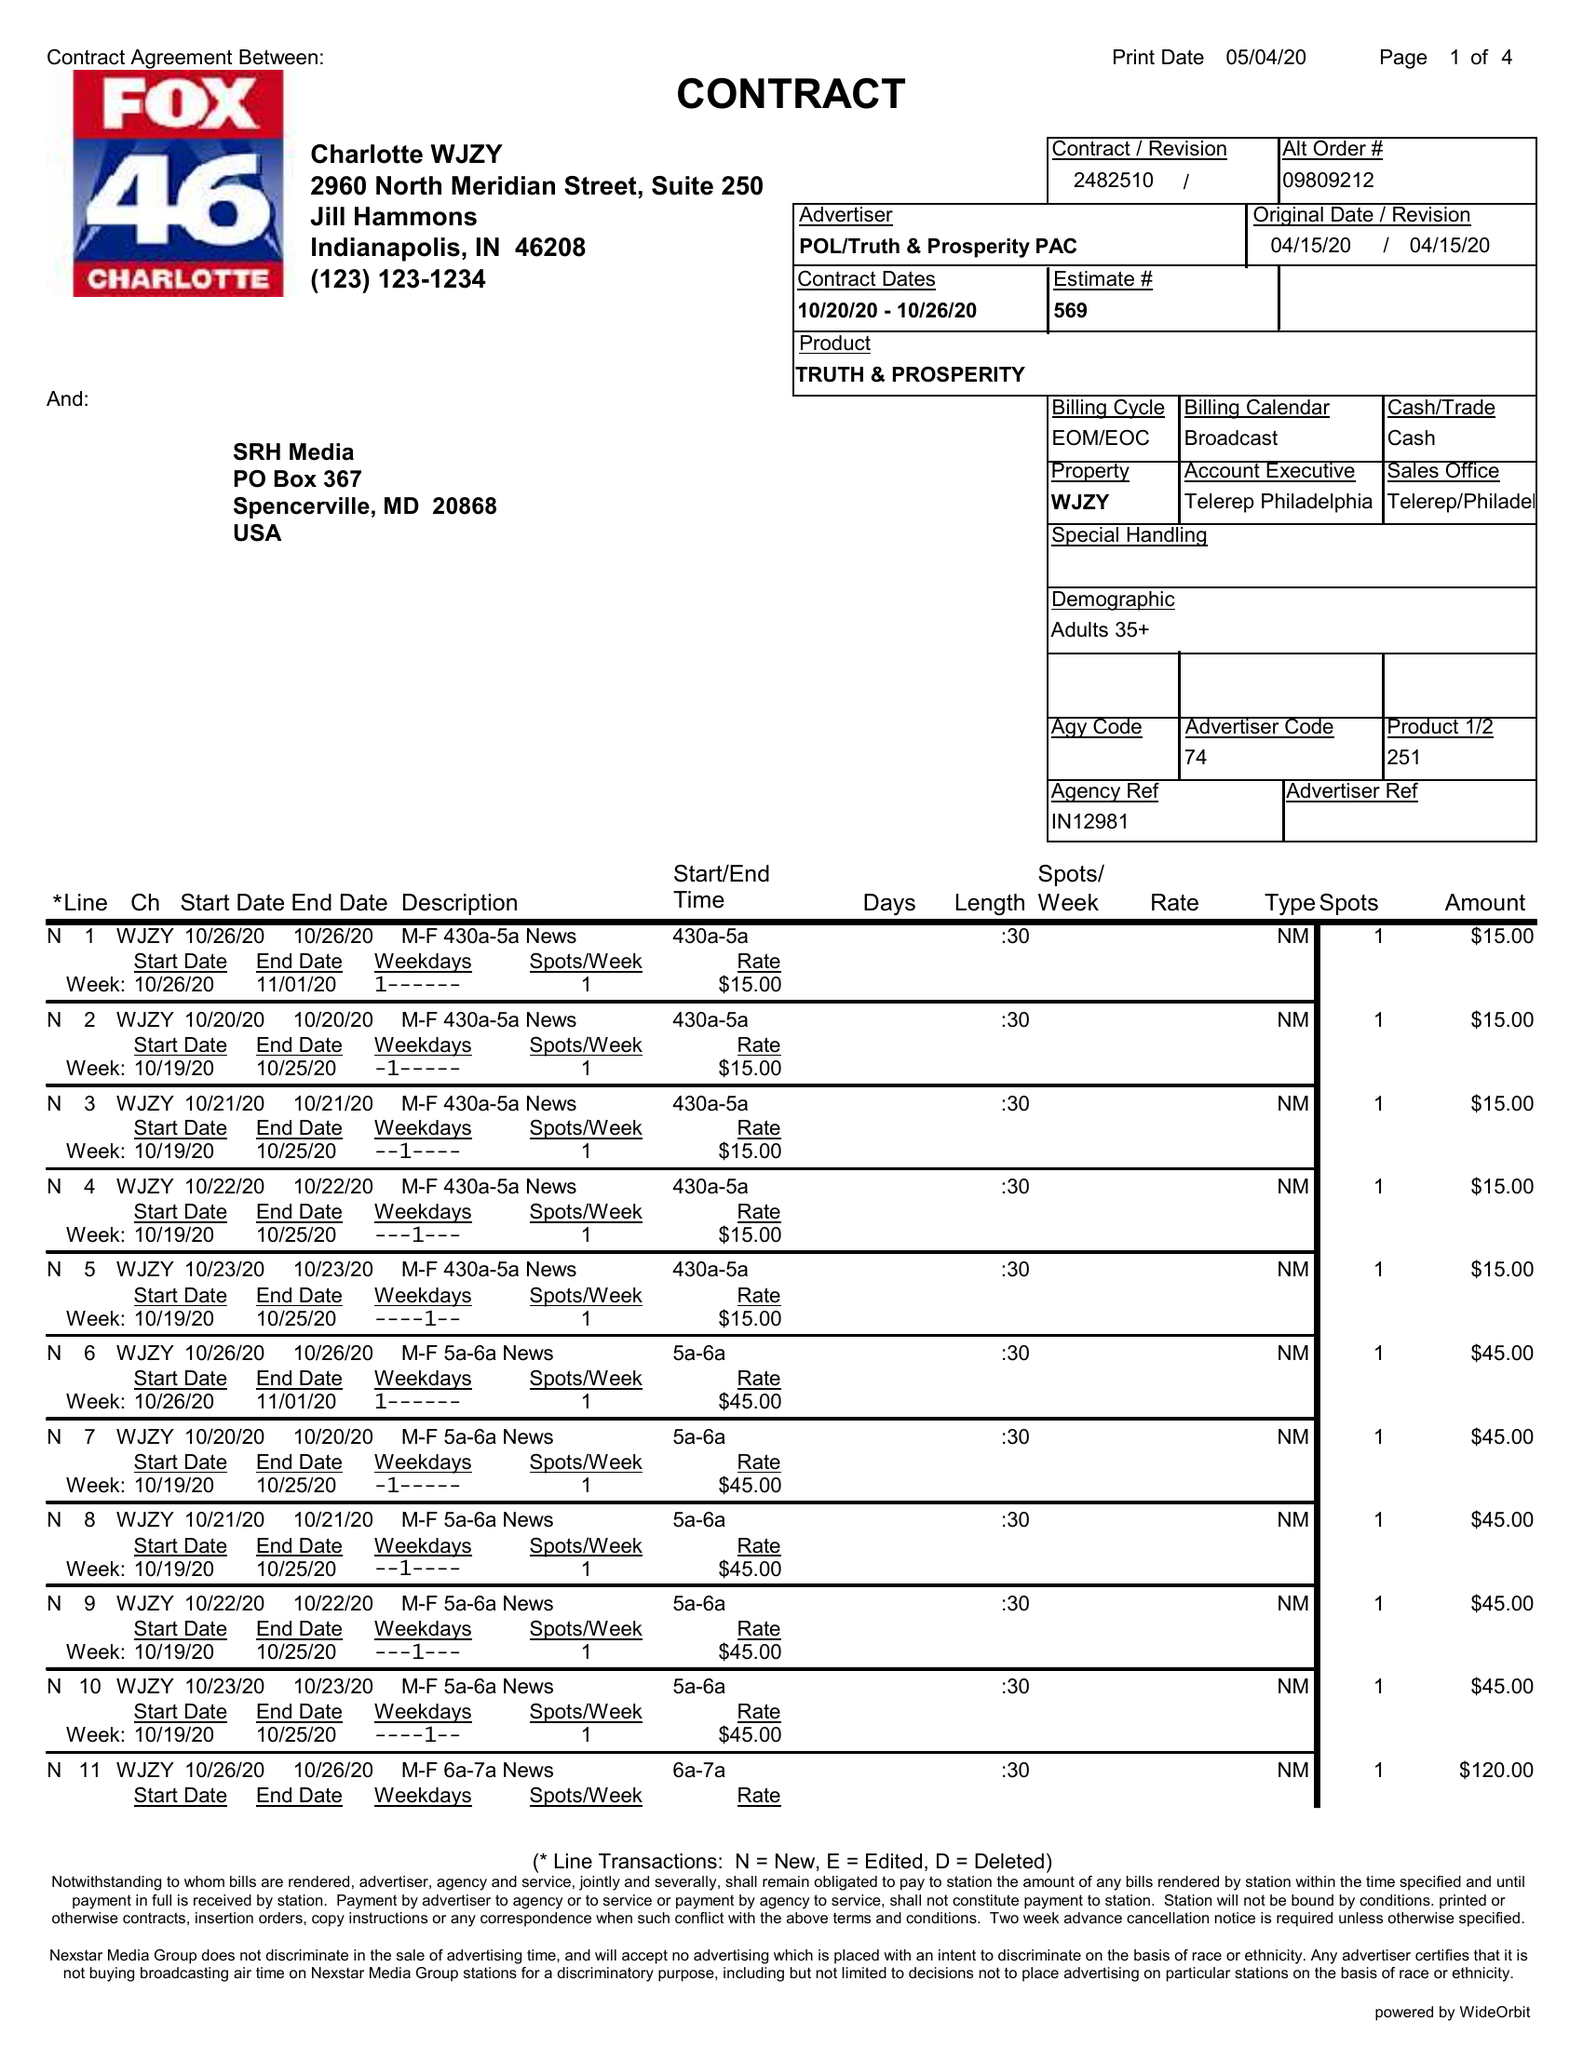What is the value for the gross_amount?
Answer the question using a single word or phrase. 4500.00 